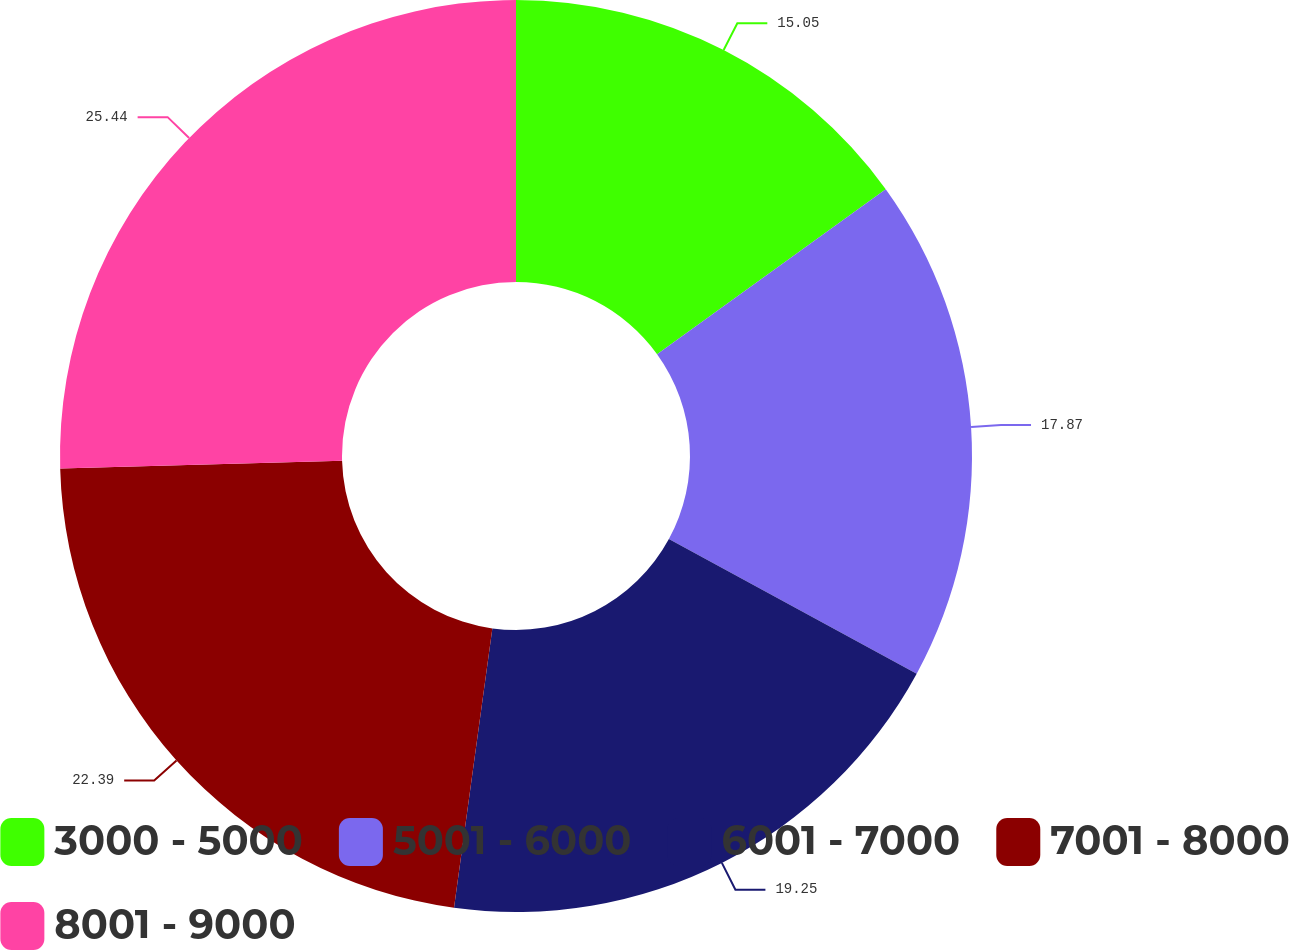Convert chart to OTSL. <chart><loc_0><loc_0><loc_500><loc_500><pie_chart><fcel>3000 - 5000<fcel>5001 - 6000<fcel>6001 - 7000<fcel>7001 - 8000<fcel>8001 - 9000<nl><fcel>15.05%<fcel>17.87%<fcel>19.25%<fcel>22.39%<fcel>25.44%<nl></chart> 